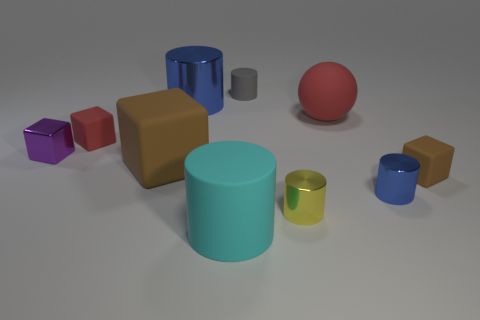Can you tell me the colors of the two largest objects in the image? Sure, the two largest objects in the image appear to be cylinders; one is blue and the other is teal. 